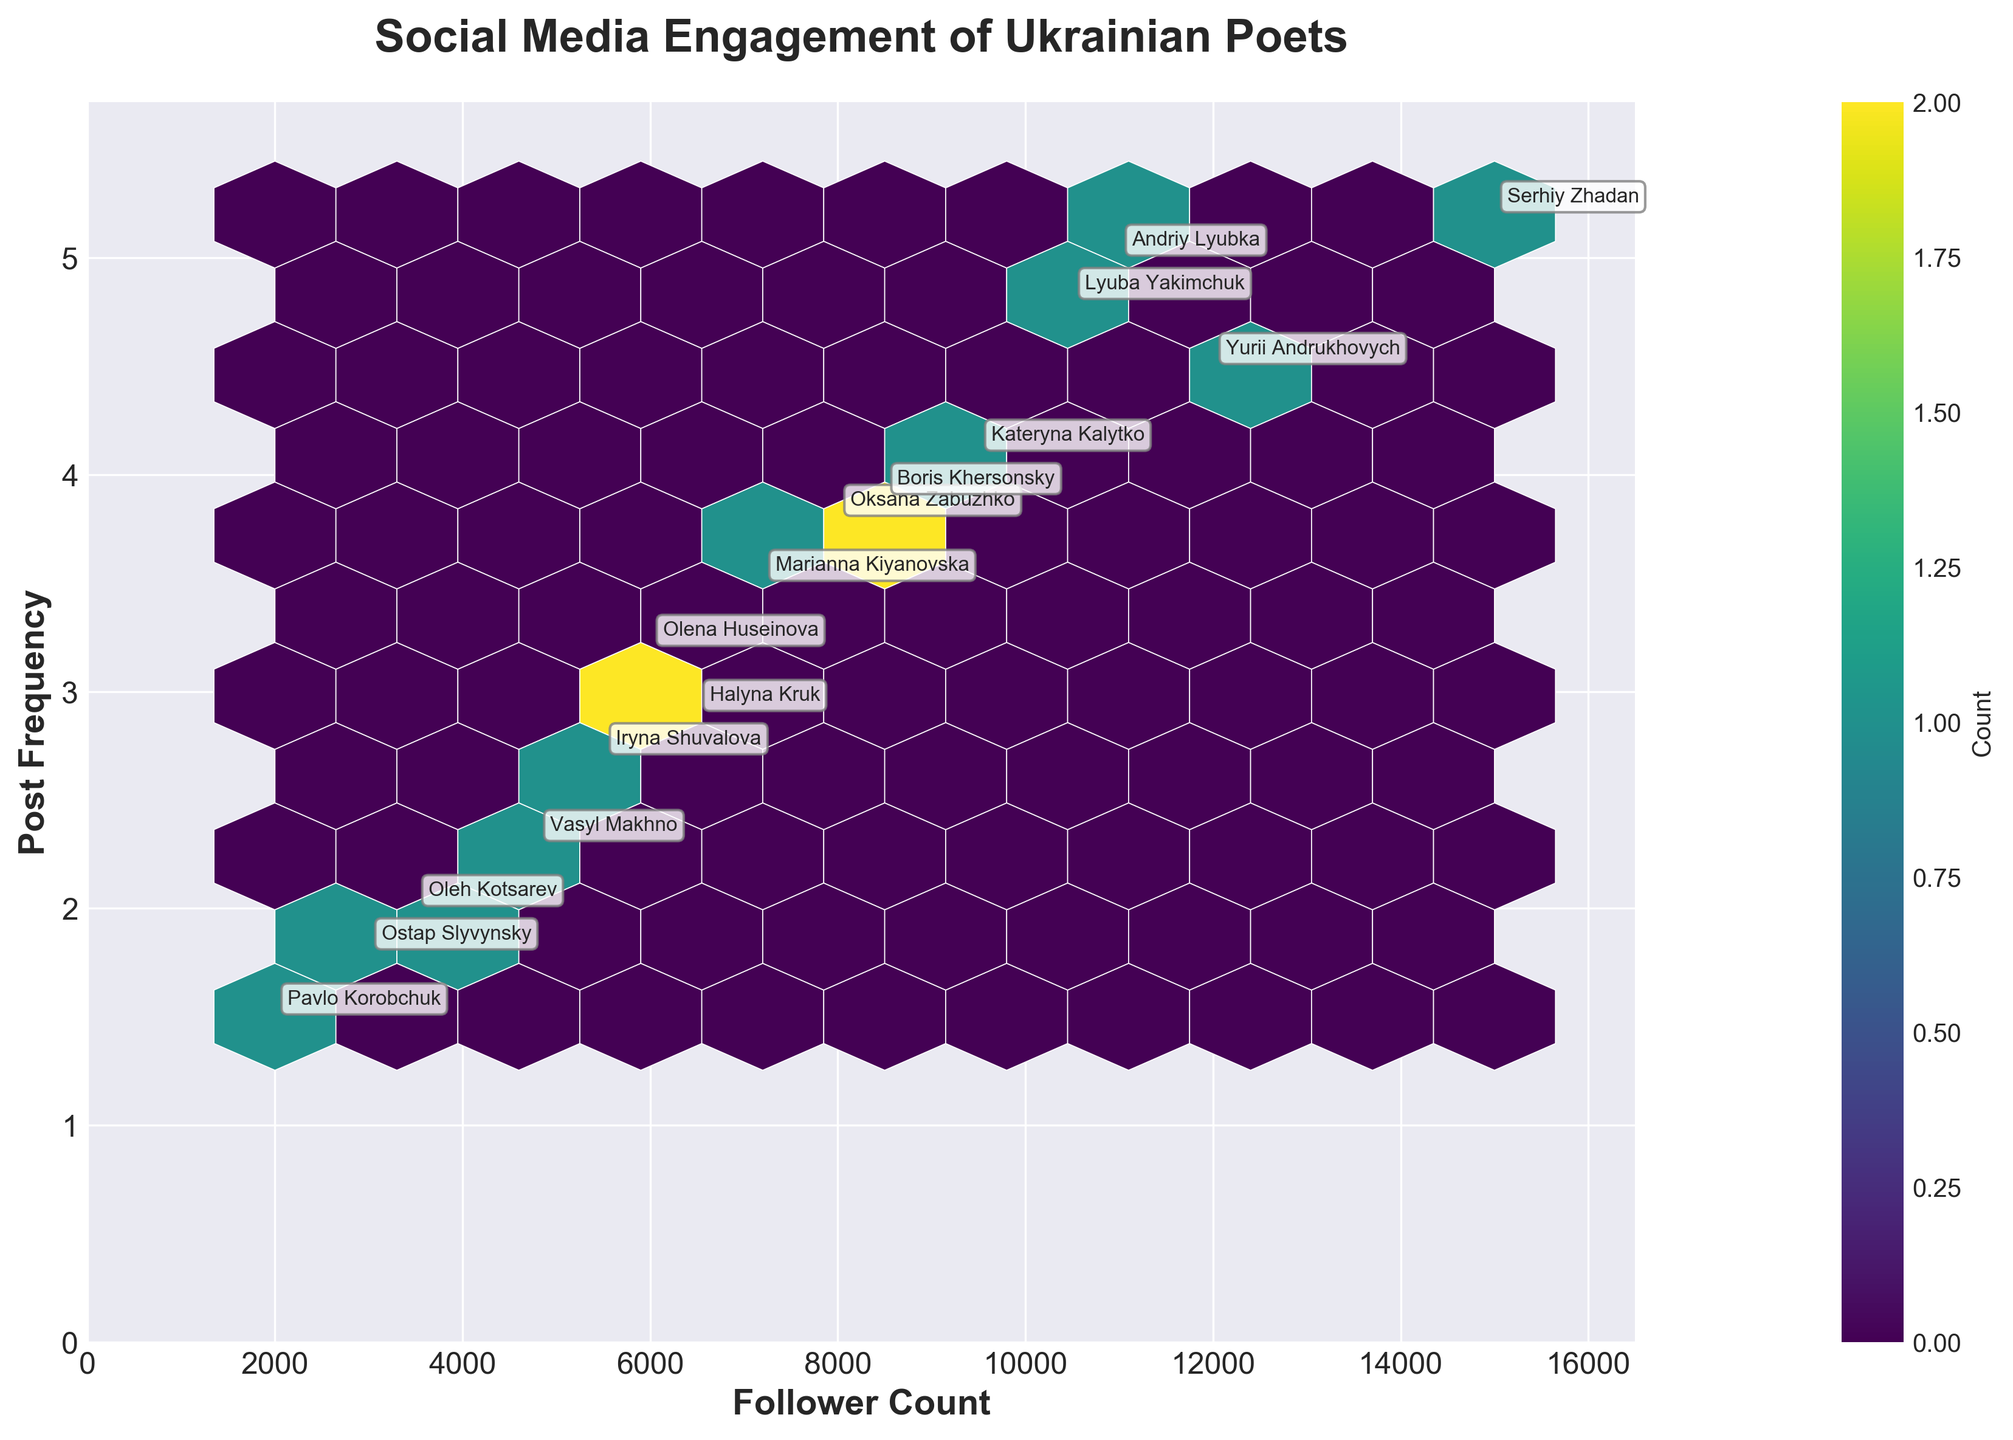What is the title of the figure? The title is located at the top of the figure in a bold and large font. It provides the primary information about the visualization's theme.
Answer: Social Media Engagement of Ukrainian Poets What is the color scheme used in the hexbin plot? The color scheme is identified by examining the color variations within the hexagons. The figure uses a specific color palette that changes to represent different densities of plotted data points.
Answer: Viridis How many poets have follower counts between 10,000 and 12,000? To find this, look along the x-axis (follower count) to identify hexagons falling between the 10,000 and 12,000 marks. There is an annotation for each poet's name, allowing for easy counting.
Answer: 4 Which poet has the highest post frequency, and what is that frequency? Locate the highest value on the y-axis (post frequency), then find the associated name annotation nearest to this value. This poet has the highest post frequency.
Answer: Andriy Lyubka, 5.0 Are there more poets with follower counts above or below 8,000? Compare the number of data points (hexagons or annotated names) above and below the 8,000 follower count mark on the x-axis to determine which side has more poets.
Answer: Below 8,000 What is the range of follower counts for poets with a post frequency between 3 and 4? Identify the hexagons that fall between post frequencies of 3 and 4 along the y-axis. Then, observe the follower count range of these hexagons on the x-axis.
Answer: 6,500 to 9,500 Which poet has the lowest follower count, and what is that count? Identify the smallest value on the x-axis (follower count) and locate the associated annotation for the poet's name nearest to this value. This poet has the lowest follower count.
Answer: Pavlo Korobchuk, 2,000 Do poets with higher follower counts generally have higher post frequencies? To answer this question, observe the overall trend indicated by the concentration and positioning of hexagons. High follower counts (right side x-axis) should align with higher post frequencies (upper side y-axis) if there's a positive correlation.
Answer: Yes, generally What is the median post frequency for the poets? List all the post frequencies, and then identify the middle value in the ordered list to determine the median post frequency. With 15 poets, the median is the 8th value in an ordered list.
Answer: 3.8 Which color hexagons represent the highest density of points? The color bar (legend) associated with the hexbin plot indicates which color corresponds to the highest density of data points. Look for the darkest shade or the one representing the highest count number.
Answer: Dark green 